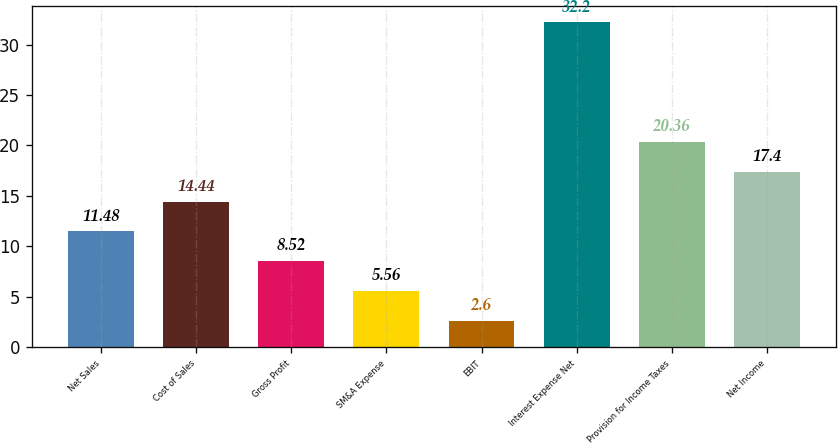Convert chart. <chart><loc_0><loc_0><loc_500><loc_500><bar_chart><fcel>Net Sales<fcel>Cost of Sales<fcel>Gross Profit<fcel>SM&A Expense<fcel>EBIT<fcel>Interest Expense Net<fcel>Provision for Income Taxes<fcel>Net Income<nl><fcel>11.48<fcel>14.44<fcel>8.52<fcel>5.56<fcel>2.6<fcel>32.2<fcel>20.36<fcel>17.4<nl></chart> 